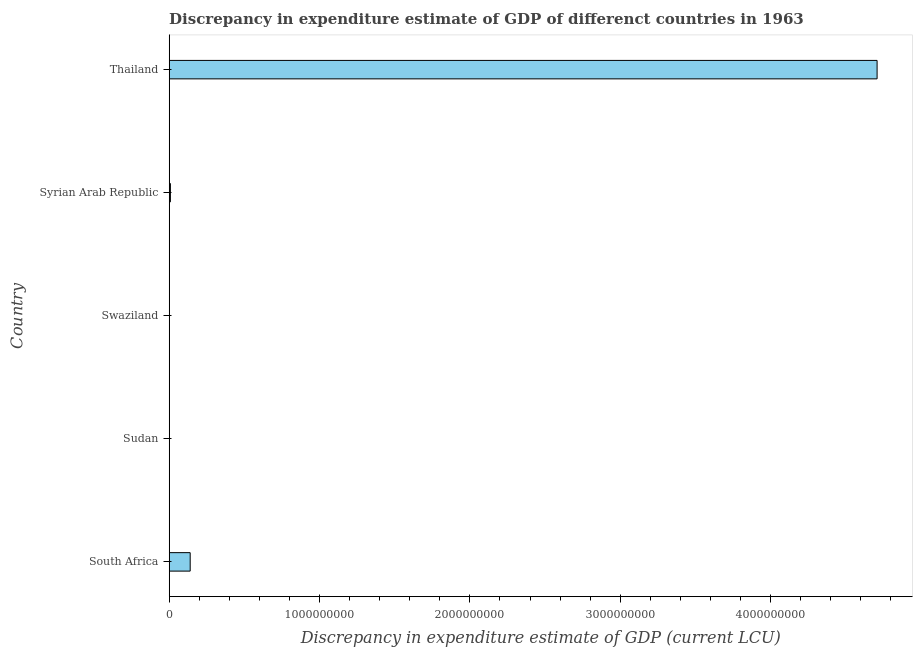Does the graph contain grids?
Make the answer very short. No. What is the title of the graph?
Your answer should be very brief. Discrepancy in expenditure estimate of GDP of differenct countries in 1963. What is the label or title of the X-axis?
Your answer should be compact. Discrepancy in expenditure estimate of GDP (current LCU). What is the discrepancy in expenditure estimate of gdp in Syrian Arab Republic?
Offer a very short reply. 7.96e+06. Across all countries, what is the maximum discrepancy in expenditure estimate of gdp?
Ensure brevity in your answer.  4.71e+09. Across all countries, what is the minimum discrepancy in expenditure estimate of gdp?
Offer a very short reply. 0. In which country was the discrepancy in expenditure estimate of gdp maximum?
Provide a short and direct response. Thailand. What is the sum of the discrepancy in expenditure estimate of gdp?
Your answer should be compact. 4.86e+09. What is the difference between the discrepancy in expenditure estimate of gdp in South Africa and Syrian Arab Republic?
Ensure brevity in your answer.  1.32e+08. What is the average discrepancy in expenditure estimate of gdp per country?
Offer a terse response. 9.71e+08. What is the median discrepancy in expenditure estimate of gdp?
Offer a very short reply. 7.96e+06. What is the ratio of the discrepancy in expenditure estimate of gdp in South Africa to that in Thailand?
Your answer should be very brief. 0.03. Is the discrepancy in expenditure estimate of gdp in Sudan less than that in Syrian Arab Republic?
Offer a very short reply. Yes. Is the difference between the discrepancy in expenditure estimate of gdp in South Africa and Thailand greater than the difference between any two countries?
Your response must be concise. No. What is the difference between the highest and the second highest discrepancy in expenditure estimate of gdp?
Make the answer very short. 4.57e+09. Is the sum of the discrepancy in expenditure estimate of gdp in South Africa and Thailand greater than the maximum discrepancy in expenditure estimate of gdp across all countries?
Your answer should be compact. Yes. What is the difference between the highest and the lowest discrepancy in expenditure estimate of gdp?
Offer a terse response. 4.71e+09. How many countries are there in the graph?
Keep it short and to the point. 5. Are the values on the major ticks of X-axis written in scientific E-notation?
Your response must be concise. No. What is the Discrepancy in expenditure estimate of GDP (current LCU) of South Africa?
Ensure brevity in your answer.  1.40e+08. What is the Discrepancy in expenditure estimate of GDP (current LCU) in Sudan?
Offer a very short reply. 2200. What is the Discrepancy in expenditure estimate of GDP (current LCU) of Swaziland?
Your answer should be very brief. 0. What is the Discrepancy in expenditure estimate of GDP (current LCU) of Syrian Arab Republic?
Your answer should be very brief. 7.96e+06. What is the Discrepancy in expenditure estimate of GDP (current LCU) of Thailand?
Offer a terse response. 4.71e+09. What is the difference between the Discrepancy in expenditure estimate of GDP (current LCU) in South Africa and Sudan?
Ensure brevity in your answer.  1.40e+08. What is the difference between the Discrepancy in expenditure estimate of GDP (current LCU) in South Africa and Syrian Arab Republic?
Provide a short and direct response. 1.32e+08. What is the difference between the Discrepancy in expenditure estimate of GDP (current LCU) in South Africa and Thailand?
Ensure brevity in your answer.  -4.57e+09. What is the difference between the Discrepancy in expenditure estimate of GDP (current LCU) in Sudan and Syrian Arab Republic?
Provide a succinct answer. -7.95e+06. What is the difference between the Discrepancy in expenditure estimate of GDP (current LCU) in Sudan and Thailand?
Offer a terse response. -4.71e+09. What is the difference between the Discrepancy in expenditure estimate of GDP (current LCU) in Syrian Arab Republic and Thailand?
Make the answer very short. -4.70e+09. What is the ratio of the Discrepancy in expenditure estimate of GDP (current LCU) in South Africa to that in Sudan?
Ensure brevity in your answer.  6.35e+04. What is the ratio of the Discrepancy in expenditure estimate of GDP (current LCU) in South Africa to that in Syrian Arab Republic?
Make the answer very short. 17.55. What is the ratio of the Discrepancy in expenditure estimate of GDP (current LCU) in Sudan to that in Syrian Arab Republic?
Offer a terse response. 0. What is the ratio of the Discrepancy in expenditure estimate of GDP (current LCU) in Sudan to that in Thailand?
Ensure brevity in your answer.  0. What is the ratio of the Discrepancy in expenditure estimate of GDP (current LCU) in Syrian Arab Republic to that in Thailand?
Your response must be concise. 0. 